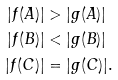Convert formula to latex. <formula><loc_0><loc_0><loc_500><loc_500>| f ( A ) | & > | g ( A ) | \\ | f ( B ) | & < | g ( B ) | \\ | f ( C ) | & = | g ( C ) | .</formula> 